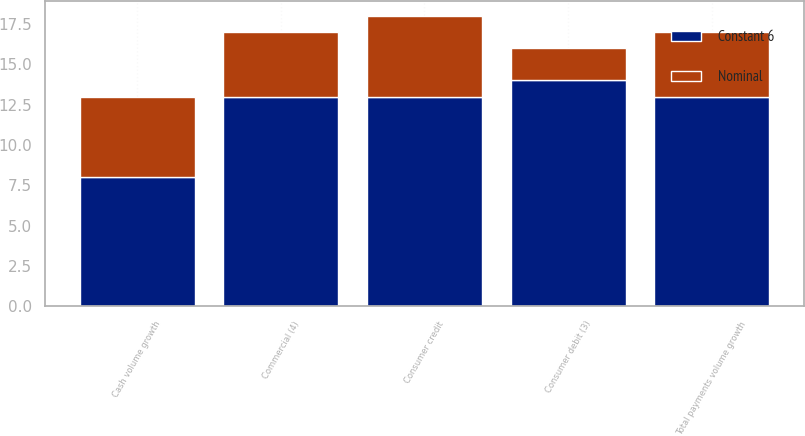Convert chart to OTSL. <chart><loc_0><loc_0><loc_500><loc_500><stacked_bar_chart><ecel><fcel>Consumer credit<fcel>Consumer debit (3)<fcel>Commercial (4)<fcel>Total payments volume growth<fcel>Cash volume growth<nl><fcel>Nominal<fcel>5<fcel>2<fcel>4<fcel>4<fcel>5<nl><fcel>Constant 6<fcel>13<fcel>14<fcel>13<fcel>13<fcel>8<nl></chart> 